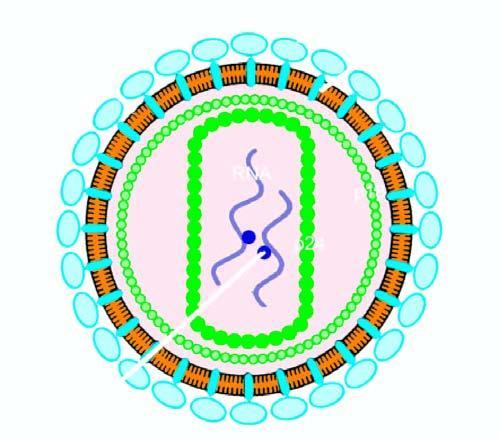what has core containing proteins, p24 and p18, two strands of viral rna, and enzyme reverse transcriptase?
Answer the question using a single word or phrase. The particle 